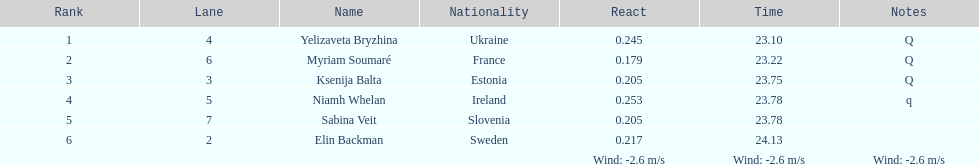What count of last names initiate with "b"? 3. 